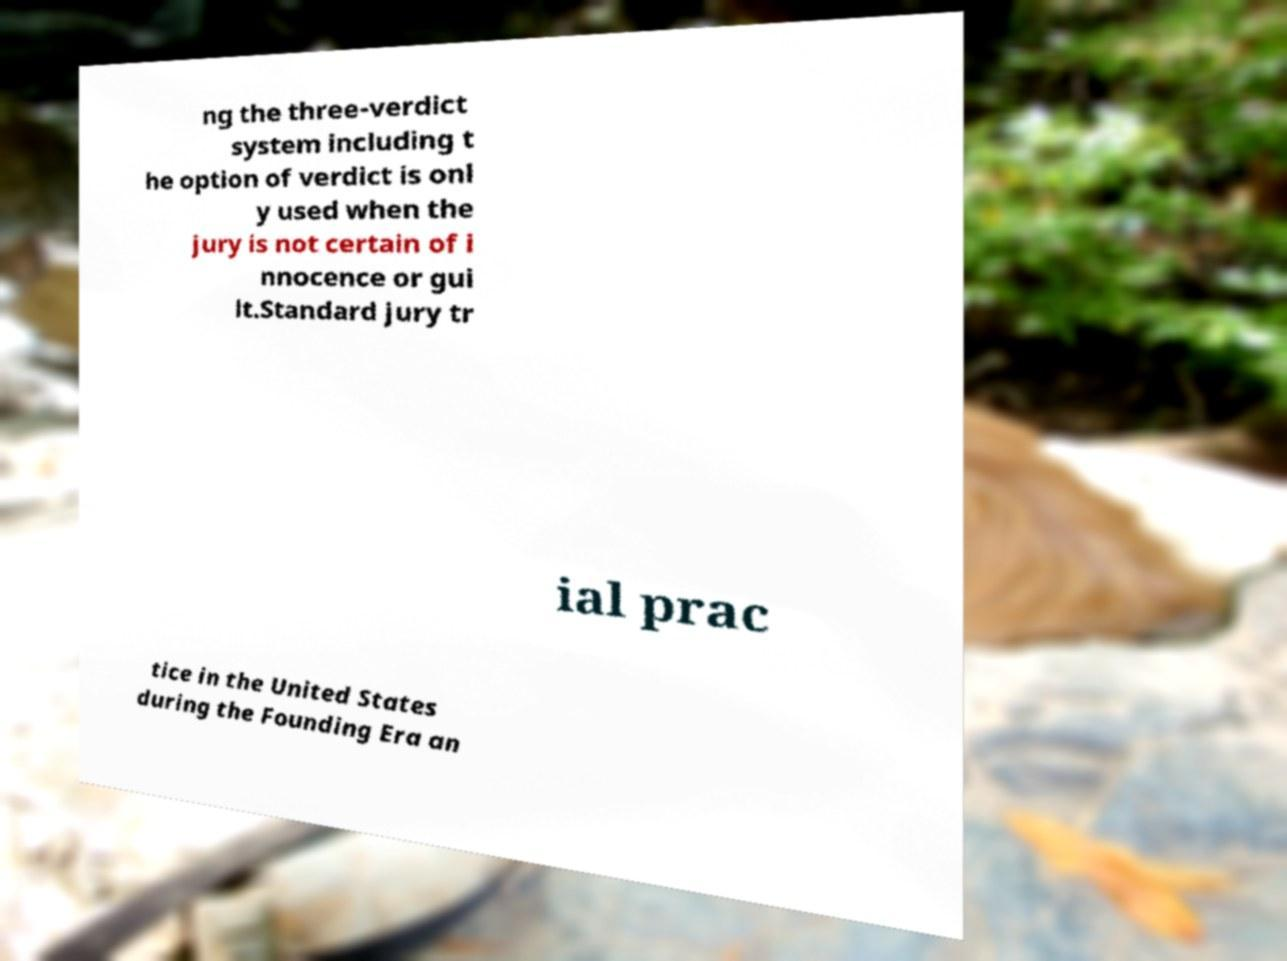There's text embedded in this image that I need extracted. Can you transcribe it verbatim? ng the three-verdict system including t he option of verdict is onl y used when the jury is not certain of i nnocence or gui lt.Standard jury tr ial prac tice in the United States during the Founding Era an 